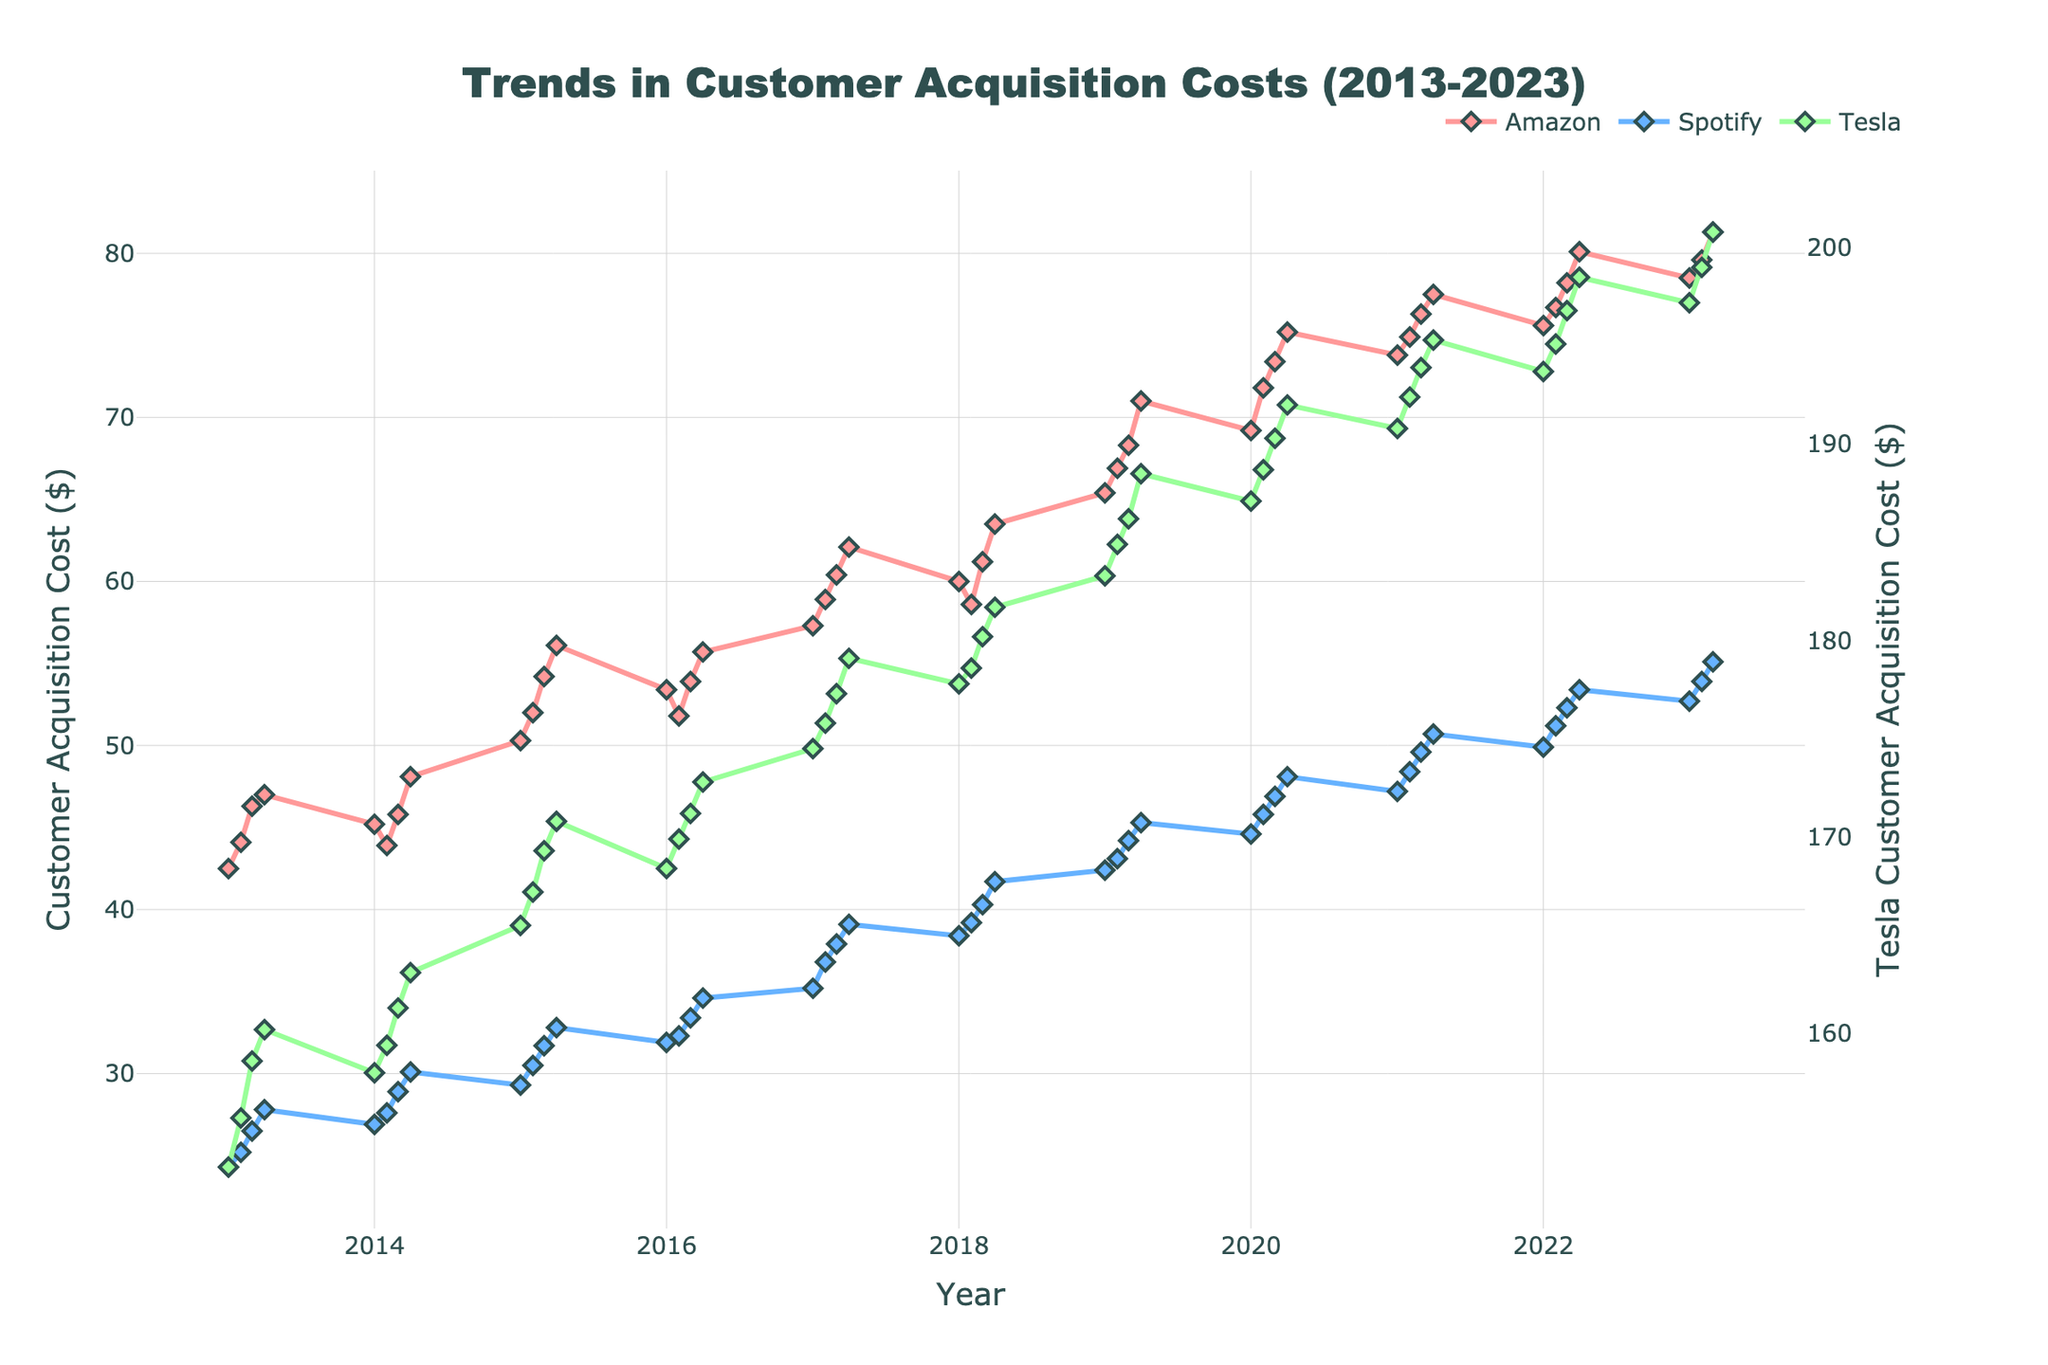What's the title of the figure? The title is usually placed at the top of the figure. According to the code, the title of the figure is "Trends in Customer Acquisition Costs (2013-2023)".
Answer: Trends in Customer Acquisition Costs (2013-2023) What are the companies represented in the figure? The companies can be identified by the unique labels in the legend of the figure. According to the data, the figure represents Amazon, Spotify, and Tesla.
Answer: Amazon, Spotify, Tesla Which company had the highest customer acquisition cost in 2023-Q3? To find this, look at the values for each company at the 2023-Q3 point on the x-axis. According to the data, Tesla has the highest value at 200.8.
Answer: Tesla What is the general trend in customer acquisition costs for Amazon from 2013 to 2023? By observing the line trend for Amazon from 2013 to 2023, it is evident that the overall trend is increasing.
Answer: Increasing How does Tesla’s customer acquisition cost in 2023-Q3 compare to its cost in 2013-Q1? Find the values for Tesla in 2023-Q3 and 2013-Q1 and compare them. Tesla's cost in 2023-Q3 is 200.8, and in 2013-Q1 it is 153.2—showing an increase over time.
Answer: Higher What is the seasonality pattern observed in Spotify's customer acquisition costs? Analyze the repeated patterns within each year on Spotify's line. Generally, there is a noticeable increase in Q2 and Q4 compared to Q1 and Q3, indicating some seasonality.
Answer: Q2 and Q4 higher Which company experienced the steepest increase in customer acquisition costs over the decade? Examine the slopes of the lines for each company from 2013 to 2023. Tesla's line shows the steepest increase when comparing the start and end points.
Answer: Tesla Did Amazon’s customer acquisition cost ever decrease from one quarter to the next within the given period? Check the lines for Amazon for any segments that slope downwards. Notably, there are drops in costs such as from 2014-Q1 to 2014-Q2.
Answer: Yes Between 2017 and 2020, which company had the most stable customer acquisition cost? To determine stability, look for the smallest fluctuations in the line. Spotify's line during 2017-2020 shows relatively less variability compared to Amazon and Tesla.
Answer: Spotify What was the average customer acquisition cost for Spotify in 2019? Find and sum the quarterly costs for Spotify in 2019 (42.4 + 43.1 + 44.2 + 45.3) and divide by 4. The calculation is (42.4 + 43.1 + 44.2 + 45.3)/4 = 175/4 = 43.75.
Answer: 43.75 